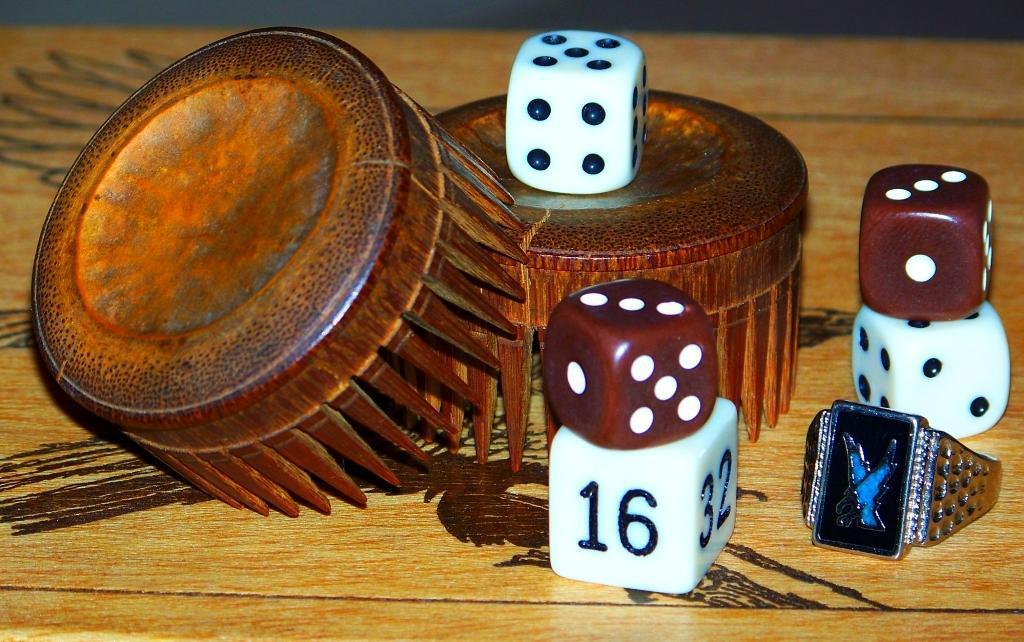What type of surface is visible in the image? There is a wooden surface in the image. What objects are on the wooden surface? There are two wooden objects on the wooden surface. Can you describe one of the wooden objects? One of the wooden objects is a dice. Can you describe the other wooden object? The other wooden object is a ring. What type of honey can be seen dripping from the goat's hair in the image? There is no goat, honey, or hair present in the image. 